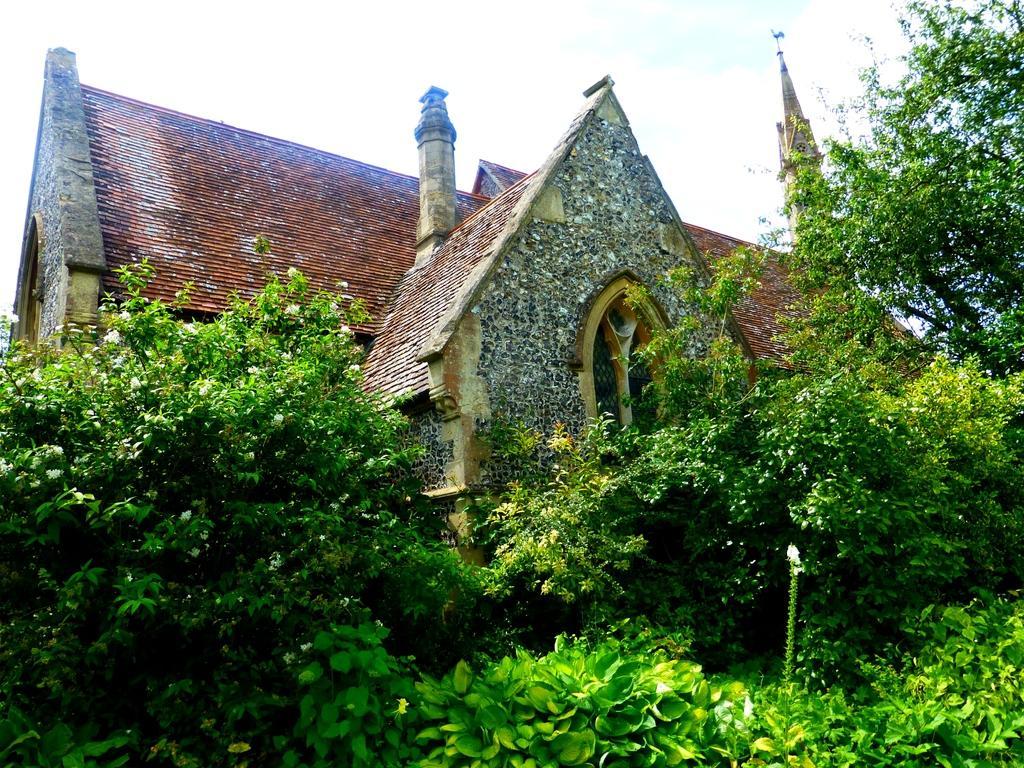Please provide a concise description of this image. In this image we can see the plants, trees, stone house and the sky in the background. 